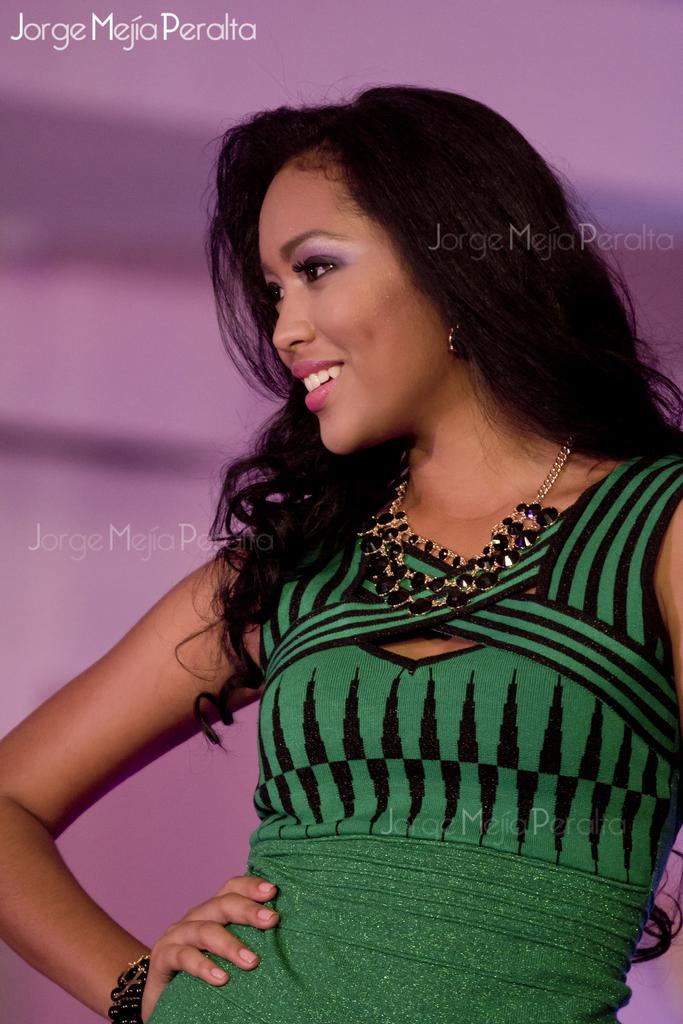What is the main subject of the image? There is a woman standing in the image. Can you describe the background of the image? The background of the image is blurred. Is there any text present in the image? Yes, there is text written on the image. What type of cloth is draped over the wooden account in the image? There is no cloth, wood, or account present in the image. 